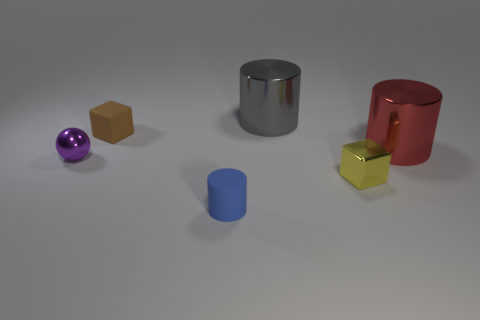Add 1 small purple things. How many objects exist? 7 Subtract all balls. How many objects are left? 5 Add 6 small cubes. How many small cubes are left? 8 Add 2 tiny red metal blocks. How many tiny red metal blocks exist? 2 Subtract 1 blue cylinders. How many objects are left? 5 Subtract all large purple rubber things. Subtract all yellow metallic blocks. How many objects are left? 5 